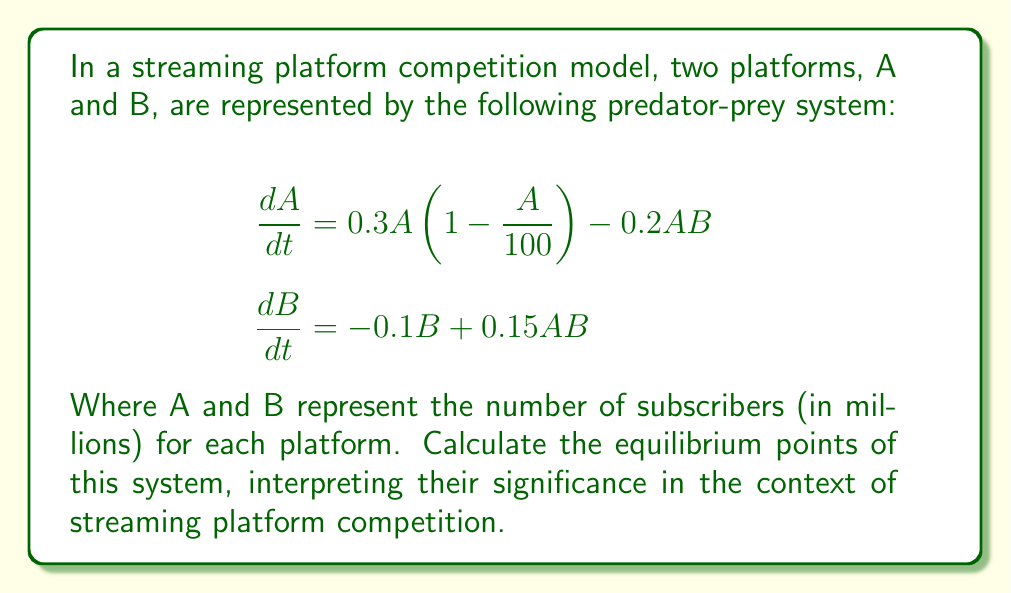What is the answer to this math problem? To find the equilibrium points, we set both equations equal to zero and solve for A and B:

1) $\frac{dA}{dt} = 0.3A(1 - \frac{A}{100}) - 0.2AB = 0$
2) $\frac{dB}{dt} = -0.1B + 0.15AB = 0$

From equation 2:
3) $-0.1B + 0.15AB = 0$
4) $B(-0.1 + 0.15A) = 0$

This gives us two possibilities:
5) $B = 0$ or $A = \frac{2}{3}$

Case 1: If $B = 0$, substitute into equation 1:
6) $0.3A(1 - \frac{A}{100}) = 0$
7) $A = 0$ or $A = 100$

This gives us two equilibrium points: $(0, 0)$ and $(100, 0)$

Case 2: If $A = \frac{2}{3}$, substitute into equation 1:
8) $0.3 \cdot \frac{2}{3}(1 - \frac{\frac{2}{3}}{100}) - 0.2 \cdot \frac{2}{3}B = 0$
9) $0.2(1 - \frac{1}{150}) - \frac{4}{30}B = 0$
10) $0.2 - \frac{1}{750} - \frac{2}{15}B = 0$
11) $B = \frac{149}{100} = 1.49$

This gives us the third equilibrium point: $(\frac{2}{3}, 1.49)$

Interpretation:
- $(0, 0)$: Both platforms have no subscribers (trivial equilibrium)
- $(100, 0)$: Platform A dominates with 100 million subscribers, B has none
- $(\frac{2}{3}, 1.49)$: Coexistence equilibrium, A has 0.67 million and B has 1.49 million subscribers
Answer: $(0, 0)$, $(100, 0)$, $(\frac{2}{3}, 1.49)$ 